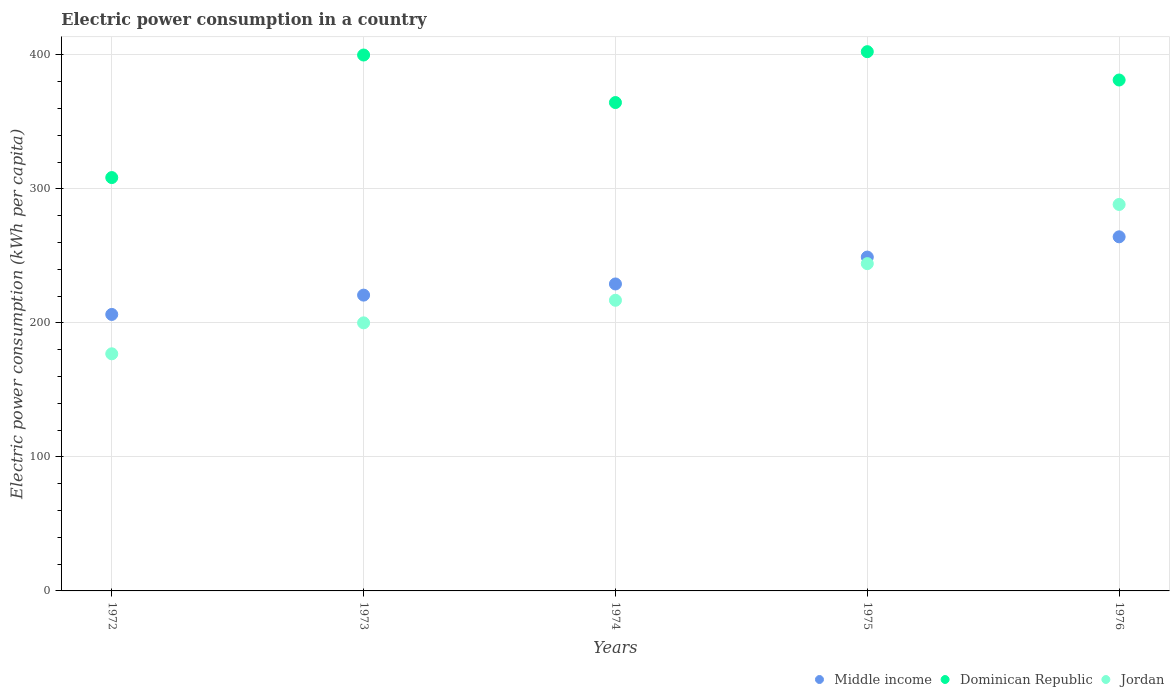How many different coloured dotlines are there?
Offer a terse response. 3. What is the electric power consumption in in Dominican Republic in 1973?
Ensure brevity in your answer.  399.84. Across all years, what is the maximum electric power consumption in in Dominican Republic?
Provide a short and direct response. 402.34. Across all years, what is the minimum electric power consumption in in Middle income?
Your answer should be compact. 206.29. In which year was the electric power consumption in in Jordan maximum?
Provide a short and direct response. 1976. What is the total electric power consumption in in Dominican Republic in the graph?
Provide a succinct answer. 1856.16. What is the difference between the electric power consumption in in Middle income in 1973 and that in 1976?
Your answer should be very brief. -43.5. What is the difference between the electric power consumption in in Dominican Republic in 1973 and the electric power consumption in in Middle income in 1974?
Your response must be concise. 170.81. What is the average electric power consumption in in Dominican Republic per year?
Your answer should be compact. 371.23. In the year 1976, what is the difference between the electric power consumption in in Dominican Republic and electric power consumption in in Jordan?
Ensure brevity in your answer.  92.86. What is the ratio of the electric power consumption in in Jordan in 1973 to that in 1974?
Your response must be concise. 0.92. Is the electric power consumption in in Dominican Republic in 1972 less than that in 1976?
Offer a very short reply. Yes. Is the difference between the electric power consumption in in Dominican Republic in 1973 and 1974 greater than the difference between the electric power consumption in in Jordan in 1973 and 1974?
Make the answer very short. Yes. What is the difference between the highest and the second highest electric power consumption in in Dominican Republic?
Make the answer very short. 2.49. What is the difference between the highest and the lowest electric power consumption in in Middle income?
Your response must be concise. 57.92. In how many years, is the electric power consumption in in Middle income greater than the average electric power consumption in in Middle income taken over all years?
Your answer should be compact. 2. Is the sum of the electric power consumption in in Jordan in 1972 and 1976 greater than the maximum electric power consumption in in Dominican Republic across all years?
Provide a succinct answer. Yes. Is the electric power consumption in in Jordan strictly greater than the electric power consumption in in Middle income over the years?
Ensure brevity in your answer.  No. Is the electric power consumption in in Middle income strictly less than the electric power consumption in in Jordan over the years?
Ensure brevity in your answer.  No. How many dotlines are there?
Offer a very short reply. 3. Are the values on the major ticks of Y-axis written in scientific E-notation?
Provide a succinct answer. No. Does the graph contain grids?
Make the answer very short. Yes. Where does the legend appear in the graph?
Offer a very short reply. Bottom right. What is the title of the graph?
Provide a short and direct response. Electric power consumption in a country. Does "Hong Kong" appear as one of the legend labels in the graph?
Your answer should be compact. No. What is the label or title of the Y-axis?
Your answer should be very brief. Electric power consumption (kWh per capita). What is the Electric power consumption (kWh per capita) in Middle income in 1972?
Offer a very short reply. 206.29. What is the Electric power consumption (kWh per capita) in Dominican Republic in 1972?
Ensure brevity in your answer.  308.41. What is the Electric power consumption (kWh per capita) in Jordan in 1972?
Make the answer very short. 176.91. What is the Electric power consumption (kWh per capita) in Middle income in 1973?
Offer a terse response. 220.7. What is the Electric power consumption (kWh per capita) of Dominican Republic in 1973?
Provide a short and direct response. 399.84. What is the Electric power consumption (kWh per capita) in Jordan in 1973?
Your answer should be compact. 200.01. What is the Electric power consumption (kWh per capita) in Middle income in 1974?
Your response must be concise. 229.03. What is the Electric power consumption (kWh per capita) in Dominican Republic in 1974?
Make the answer very short. 364.38. What is the Electric power consumption (kWh per capita) of Jordan in 1974?
Give a very brief answer. 216.86. What is the Electric power consumption (kWh per capita) of Middle income in 1975?
Ensure brevity in your answer.  249.09. What is the Electric power consumption (kWh per capita) of Dominican Republic in 1975?
Your response must be concise. 402.34. What is the Electric power consumption (kWh per capita) in Jordan in 1975?
Provide a short and direct response. 244.2. What is the Electric power consumption (kWh per capita) of Middle income in 1976?
Ensure brevity in your answer.  264.2. What is the Electric power consumption (kWh per capita) of Dominican Republic in 1976?
Ensure brevity in your answer.  381.2. What is the Electric power consumption (kWh per capita) of Jordan in 1976?
Give a very brief answer. 288.34. Across all years, what is the maximum Electric power consumption (kWh per capita) in Middle income?
Your response must be concise. 264.2. Across all years, what is the maximum Electric power consumption (kWh per capita) of Dominican Republic?
Give a very brief answer. 402.34. Across all years, what is the maximum Electric power consumption (kWh per capita) of Jordan?
Keep it short and to the point. 288.34. Across all years, what is the minimum Electric power consumption (kWh per capita) in Middle income?
Offer a very short reply. 206.29. Across all years, what is the minimum Electric power consumption (kWh per capita) in Dominican Republic?
Offer a very short reply. 308.41. Across all years, what is the minimum Electric power consumption (kWh per capita) of Jordan?
Your answer should be very brief. 176.91. What is the total Electric power consumption (kWh per capita) in Middle income in the graph?
Your answer should be very brief. 1169.3. What is the total Electric power consumption (kWh per capita) of Dominican Republic in the graph?
Offer a terse response. 1856.16. What is the total Electric power consumption (kWh per capita) in Jordan in the graph?
Offer a very short reply. 1126.31. What is the difference between the Electric power consumption (kWh per capita) of Middle income in 1972 and that in 1973?
Your answer should be compact. -14.41. What is the difference between the Electric power consumption (kWh per capita) in Dominican Republic in 1972 and that in 1973?
Your response must be concise. -91.43. What is the difference between the Electric power consumption (kWh per capita) of Jordan in 1972 and that in 1973?
Ensure brevity in your answer.  -23.09. What is the difference between the Electric power consumption (kWh per capita) in Middle income in 1972 and that in 1974?
Provide a short and direct response. -22.74. What is the difference between the Electric power consumption (kWh per capita) in Dominican Republic in 1972 and that in 1974?
Keep it short and to the point. -55.97. What is the difference between the Electric power consumption (kWh per capita) of Jordan in 1972 and that in 1974?
Provide a succinct answer. -39.94. What is the difference between the Electric power consumption (kWh per capita) in Middle income in 1972 and that in 1975?
Your answer should be very brief. -42.8. What is the difference between the Electric power consumption (kWh per capita) of Dominican Republic in 1972 and that in 1975?
Your response must be concise. -93.93. What is the difference between the Electric power consumption (kWh per capita) in Jordan in 1972 and that in 1975?
Your response must be concise. -67.28. What is the difference between the Electric power consumption (kWh per capita) of Middle income in 1972 and that in 1976?
Provide a short and direct response. -57.92. What is the difference between the Electric power consumption (kWh per capita) of Dominican Republic in 1972 and that in 1976?
Ensure brevity in your answer.  -72.79. What is the difference between the Electric power consumption (kWh per capita) in Jordan in 1972 and that in 1976?
Provide a short and direct response. -111.42. What is the difference between the Electric power consumption (kWh per capita) of Middle income in 1973 and that in 1974?
Your response must be concise. -8.33. What is the difference between the Electric power consumption (kWh per capita) in Dominican Republic in 1973 and that in 1974?
Your response must be concise. 35.46. What is the difference between the Electric power consumption (kWh per capita) of Jordan in 1973 and that in 1974?
Your answer should be very brief. -16.85. What is the difference between the Electric power consumption (kWh per capita) of Middle income in 1973 and that in 1975?
Your response must be concise. -28.39. What is the difference between the Electric power consumption (kWh per capita) in Dominican Republic in 1973 and that in 1975?
Offer a very short reply. -2.49. What is the difference between the Electric power consumption (kWh per capita) in Jordan in 1973 and that in 1975?
Give a very brief answer. -44.19. What is the difference between the Electric power consumption (kWh per capita) in Middle income in 1973 and that in 1976?
Provide a succinct answer. -43.5. What is the difference between the Electric power consumption (kWh per capita) in Dominican Republic in 1973 and that in 1976?
Your response must be concise. 18.64. What is the difference between the Electric power consumption (kWh per capita) of Jordan in 1973 and that in 1976?
Your answer should be compact. -88.33. What is the difference between the Electric power consumption (kWh per capita) of Middle income in 1974 and that in 1975?
Your answer should be very brief. -20.06. What is the difference between the Electric power consumption (kWh per capita) in Dominican Republic in 1974 and that in 1975?
Give a very brief answer. -37.95. What is the difference between the Electric power consumption (kWh per capita) of Jordan in 1974 and that in 1975?
Your response must be concise. -27.34. What is the difference between the Electric power consumption (kWh per capita) in Middle income in 1974 and that in 1976?
Make the answer very short. -35.17. What is the difference between the Electric power consumption (kWh per capita) in Dominican Republic in 1974 and that in 1976?
Ensure brevity in your answer.  -16.82. What is the difference between the Electric power consumption (kWh per capita) of Jordan in 1974 and that in 1976?
Keep it short and to the point. -71.48. What is the difference between the Electric power consumption (kWh per capita) in Middle income in 1975 and that in 1976?
Your answer should be very brief. -15.11. What is the difference between the Electric power consumption (kWh per capita) in Dominican Republic in 1975 and that in 1976?
Keep it short and to the point. 21.14. What is the difference between the Electric power consumption (kWh per capita) of Jordan in 1975 and that in 1976?
Offer a terse response. -44.14. What is the difference between the Electric power consumption (kWh per capita) of Middle income in 1972 and the Electric power consumption (kWh per capita) of Dominican Republic in 1973?
Keep it short and to the point. -193.56. What is the difference between the Electric power consumption (kWh per capita) in Middle income in 1972 and the Electric power consumption (kWh per capita) in Jordan in 1973?
Your answer should be very brief. 6.28. What is the difference between the Electric power consumption (kWh per capita) in Dominican Republic in 1972 and the Electric power consumption (kWh per capita) in Jordan in 1973?
Offer a terse response. 108.4. What is the difference between the Electric power consumption (kWh per capita) in Middle income in 1972 and the Electric power consumption (kWh per capita) in Dominican Republic in 1974?
Your response must be concise. -158.1. What is the difference between the Electric power consumption (kWh per capita) of Middle income in 1972 and the Electric power consumption (kWh per capita) of Jordan in 1974?
Provide a succinct answer. -10.57. What is the difference between the Electric power consumption (kWh per capita) of Dominican Republic in 1972 and the Electric power consumption (kWh per capita) of Jordan in 1974?
Your response must be concise. 91.55. What is the difference between the Electric power consumption (kWh per capita) in Middle income in 1972 and the Electric power consumption (kWh per capita) in Dominican Republic in 1975?
Your answer should be compact. -196.05. What is the difference between the Electric power consumption (kWh per capita) of Middle income in 1972 and the Electric power consumption (kWh per capita) of Jordan in 1975?
Keep it short and to the point. -37.91. What is the difference between the Electric power consumption (kWh per capita) of Dominican Republic in 1972 and the Electric power consumption (kWh per capita) of Jordan in 1975?
Give a very brief answer. 64.21. What is the difference between the Electric power consumption (kWh per capita) in Middle income in 1972 and the Electric power consumption (kWh per capita) in Dominican Republic in 1976?
Keep it short and to the point. -174.91. What is the difference between the Electric power consumption (kWh per capita) in Middle income in 1972 and the Electric power consumption (kWh per capita) in Jordan in 1976?
Make the answer very short. -82.05. What is the difference between the Electric power consumption (kWh per capita) in Dominican Republic in 1972 and the Electric power consumption (kWh per capita) in Jordan in 1976?
Provide a short and direct response. 20.07. What is the difference between the Electric power consumption (kWh per capita) in Middle income in 1973 and the Electric power consumption (kWh per capita) in Dominican Republic in 1974?
Make the answer very short. -143.68. What is the difference between the Electric power consumption (kWh per capita) in Middle income in 1973 and the Electric power consumption (kWh per capita) in Jordan in 1974?
Ensure brevity in your answer.  3.84. What is the difference between the Electric power consumption (kWh per capita) in Dominican Republic in 1973 and the Electric power consumption (kWh per capita) in Jordan in 1974?
Provide a succinct answer. 182.99. What is the difference between the Electric power consumption (kWh per capita) in Middle income in 1973 and the Electric power consumption (kWh per capita) in Dominican Republic in 1975?
Your answer should be compact. -181.64. What is the difference between the Electric power consumption (kWh per capita) in Middle income in 1973 and the Electric power consumption (kWh per capita) in Jordan in 1975?
Make the answer very short. -23.5. What is the difference between the Electric power consumption (kWh per capita) in Dominican Republic in 1973 and the Electric power consumption (kWh per capita) in Jordan in 1975?
Make the answer very short. 155.64. What is the difference between the Electric power consumption (kWh per capita) in Middle income in 1973 and the Electric power consumption (kWh per capita) in Dominican Republic in 1976?
Your response must be concise. -160.5. What is the difference between the Electric power consumption (kWh per capita) of Middle income in 1973 and the Electric power consumption (kWh per capita) of Jordan in 1976?
Keep it short and to the point. -67.64. What is the difference between the Electric power consumption (kWh per capita) of Dominican Republic in 1973 and the Electric power consumption (kWh per capita) of Jordan in 1976?
Ensure brevity in your answer.  111.5. What is the difference between the Electric power consumption (kWh per capita) in Middle income in 1974 and the Electric power consumption (kWh per capita) in Dominican Republic in 1975?
Your answer should be very brief. -173.31. What is the difference between the Electric power consumption (kWh per capita) in Middle income in 1974 and the Electric power consumption (kWh per capita) in Jordan in 1975?
Your answer should be compact. -15.17. What is the difference between the Electric power consumption (kWh per capita) in Dominican Republic in 1974 and the Electric power consumption (kWh per capita) in Jordan in 1975?
Your response must be concise. 120.18. What is the difference between the Electric power consumption (kWh per capita) in Middle income in 1974 and the Electric power consumption (kWh per capita) in Dominican Republic in 1976?
Ensure brevity in your answer.  -152.17. What is the difference between the Electric power consumption (kWh per capita) of Middle income in 1974 and the Electric power consumption (kWh per capita) of Jordan in 1976?
Your response must be concise. -59.31. What is the difference between the Electric power consumption (kWh per capita) in Dominican Republic in 1974 and the Electric power consumption (kWh per capita) in Jordan in 1976?
Make the answer very short. 76.04. What is the difference between the Electric power consumption (kWh per capita) in Middle income in 1975 and the Electric power consumption (kWh per capita) in Dominican Republic in 1976?
Your response must be concise. -132.11. What is the difference between the Electric power consumption (kWh per capita) in Middle income in 1975 and the Electric power consumption (kWh per capita) in Jordan in 1976?
Your answer should be very brief. -39.25. What is the difference between the Electric power consumption (kWh per capita) of Dominican Republic in 1975 and the Electric power consumption (kWh per capita) of Jordan in 1976?
Ensure brevity in your answer.  114. What is the average Electric power consumption (kWh per capita) of Middle income per year?
Keep it short and to the point. 233.86. What is the average Electric power consumption (kWh per capita) in Dominican Republic per year?
Make the answer very short. 371.23. What is the average Electric power consumption (kWh per capita) of Jordan per year?
Your answer should be compact. 225.26. In the year 1972, what is the difference between the Electric power consumption (kWh per capita) of Middle income and Electric power consumption (kWh per capita) of Dominican Republic?
Your answer should be compact. -102.12. In the year 1972, what is the difference between the Electric power consumption (kWh per capita) in Middle income and Electric power consumption (kWh per capita) in Jordan?
Ensure brevity in your answer.  29.37. In the year 1972, what is the difference between the Electric power consumption (kWh per capita) of Dominican Republic and Electric power consumption (kWh per capita) of Jordan?
Provide a succinct answer. 131.49. In the year 1973, what is the difference between the Electric power consumption (kWh per capita) in Middle income and Electric power consumption (kWh per capita) in Dominican Republic?
Offer a terse response. -179.14. In the year 1973, what is the difference between the Electric power consumption (kWh per capita) of Middle income and Electric power consumption (kWh per capita) of Jordan?
Provide a short and direct response. 20.69. In the year 1973, what is the difference between the Electric power consumption (kWh per capita) of Dominican Republic and Electric power consumption (kWh per capita) of Jordan?
Provide a succinct answer. 199.83. In the year 1974, what is the difference between the Electric power consumption (kWh per capita) in Middle income and Electric power consumption (kWh per capita) in Dominican Republic?
Your answer should be very brief. -135.35. In the year 1974, what is the difference between the Electric power consumption (kWh per capita) of Middle income and Electric power consumption (kWh per capita) of Jordan?
Offer a very short reply. 12.17. In the year 1974, what is the difference between the Electric power consumption (kWh per capita) in Dominican Republic and Electric power consumption (kWh per capita) in Jordan?
Your response must be concise. 147.53. In the year 1975, what is the difference between the Electric power consumption (kWh per capita) of Middle income and Electric power consumption (kWh per capita) of Dominican Republic?
Provide a short and direct response. -153.25. In the year 1975, what is the difference between the Electric power consumption (kWh per capita) in Middle income and Electric power consumption (kWh per capita) in Jordan?
Your answer should be compact. 4.89. In the year 1975, what is the difference between the Electric power consumption (kWh per capita) in Dominican Republic and Electric power consumption (kWh per capita) in Jordan?
Keep it short and to the point. 158.14. In the year 1976, what is the difference between the Electric power consumption (kWh per capita) of Middle income and Electric power consumption (kWh per capita) of Dominican Republic?
Your response must be concise. -117. In the year 1976, what is the difference between the Electric power consumption (kWh per capita) in Middle income and Electric power consumption (kWh per capita) in Jordan?
Provide a short and direct response. -24.14. In the year 1976, what is the difference between the Electric power consumption (kWh per capita) in Dominican Republic and Electric power consumption (kWh per capita) in Jordan?
Your response must be concise. 92.86. What is the ratio of the Electric power consumption (kWh per capita) in Middle income in 1972 to that in 1973?
Provide a short and direct response. 0.93. What is the ratio of the Electric power consumption (kWh per capita) in Dominican Republic in 1972 to that in 1973?
Your answer should be very brief. 0.77. What is the ratio of the Electric power consumption (kWh per capita) of Jordan in 1972 to that in 1973?
Make the answer very short. 0.88. What is the ratio of the Electric power consumption (kWh per capita) in Middle income in 1972 to that in 1974?
Give a very brief answer. 0.9. What is the ratio of the Electric power consumption (kWh per capita) of Dominican Republic in 1972 to that in 1974?
Your answer should be very brief. 0.85. What is the ratio of the Electric power consumption (kWh per capita) of Jordan in 1972 to that in 1974?
Your answer should be compact. 0.82. What is the ratio of the Electric power consumption (kWh per capita) in Middle income in 1972 to that in 1975?
Keep it short and to the point. 0.83. What is the ratio of the Electric power consumption (kWh per capita) in Dominican Republic in 1972 to that in 1975?
Ensure brevity in your answer.  0.77. What is the ratio of the Electric power consumption (kWh per capita) of Jordan in 1972 to that in 1975?
Your answer should be very brief. 0.72. What is the ratio of the Electric power consumption (kWh per capita) of Middle income in 1972 to that in 1976?
Give a very brief answer. 0.78. What is the ratio of the Electric power consumption (kWh per capita) in Dominican Republic in 1972 to that in 1976?
Make the answer very short. 0.81. What is the ratio of the Electric power consumption (kWh per capita) in Jordan in 1972 to that in 1976?
Ensure brevity in your answer.  0.61. What is the ratio of the Electric power consumption (kWh per capita) in Middle income in 1973 to that in 1974?
Give a very brief answer. 0.96. What is the ratio of the Electric power consumption (kWh per capita) in Dominican Republic in 1973 to that in 1974?
Provide a short and direct response. 1.1. What is the ratio of the Electric power consumption (kWh per capita) of Jordan in 1973 to that in 1974?
Give a very brief answer. 0.92. What is the ratio of the Electric power consumption (kWh per capita) of Middle income in 1973 to that in 1975?
Offer a very short reply. 0.89. What is the ratio of the Electric power consumption (kWh per capita) in Jordan in 1973 to that in 1975?
Provide a succinct answer. 0.82. What is the ratio of the Electric power consumption (kWh per capita) of Middle income in 1973 to that in 1976?
Provide a short and direct response. 0.84. What is the ratio of the Electric power consumption (kWh per capita) in Dominican Republic in 1973 to that in 1976?
Your response must be concise. 1.05. What is the ratio of the Electric power consumption (kWh per capita) of Jordan in 1973 to that in 1976?
Ensure brevity in your answer.  0.69. What is the ratio of the Electric power consumption (kWh per capita) in Middle income in 1974 to that in 1975?
Offer a terse response. 0.92. What is the ratio of the Electric power consumption (kWh per capita) in Dominican Republic in 1974 to that in 1975?
Offer a very short reply. 0.91. What is the ratio of the Electric power consumption (kWh per capita) of Jordan in 1974 to that in 1975?
Keep it short and to the point. 0.89. What is the ratio of the Electric power consumption (kWh per capita) of Middle income in 1974 to that in 1976?
Ensure brevity in your answer.  0.87. What is the ratio of the Electric power consumption (kWh per capita) in Dominican Republic in 1974 to that in 1976?
Your answer should be compact. 0.96. What is the ratio of the Electric power consumption (kWh per capita) in Jordan in 1974 to that in 1976?
Offer a terse response. 0.75. What is the ratio of the Electric power consumption (kWh per capita) of Middle income in 1975 to that in 1976?
Your answer should be very brief. 0.94. What is the ratio of the Electric power consumption (kWh per capita) in Dominican Republic in 1975 to that in 1976?
Provide a short and direct response. 1.06. What is the ratio of the Electric power consumption (kWh per capita) in Jordan in 1975 to that in 1976?
Make the answer very short. 0.85. What is the difference between the highest and the second highest Electric power consumption (kWh per capita) in Middle income?
Your response must be concise. 15.11. What is the difference between the highest and the second highest Electric power consumption (kWh per capita) in Dominican Republic?
Provide a short and direct response. 2.49. What is the difference between the highest and the second highest Electric power consumption (kWh per capita) in Jordan?
Provide a short and direct response. 44.14. What is the difference between the highest and the lowest Electric power consumption (kWh per capita) in Middle income?
Your answer should be very brief. 57.92. What is the difference between the highest and the lowest Electric power consumption (kWh per capita) in Dominican Republic?
Give a very brief answer. 93.93. What is the difference between the highest and the lowest Electric power consumption (kWh per capita) of Jordan?
Offer a very short reply. 111.42. 